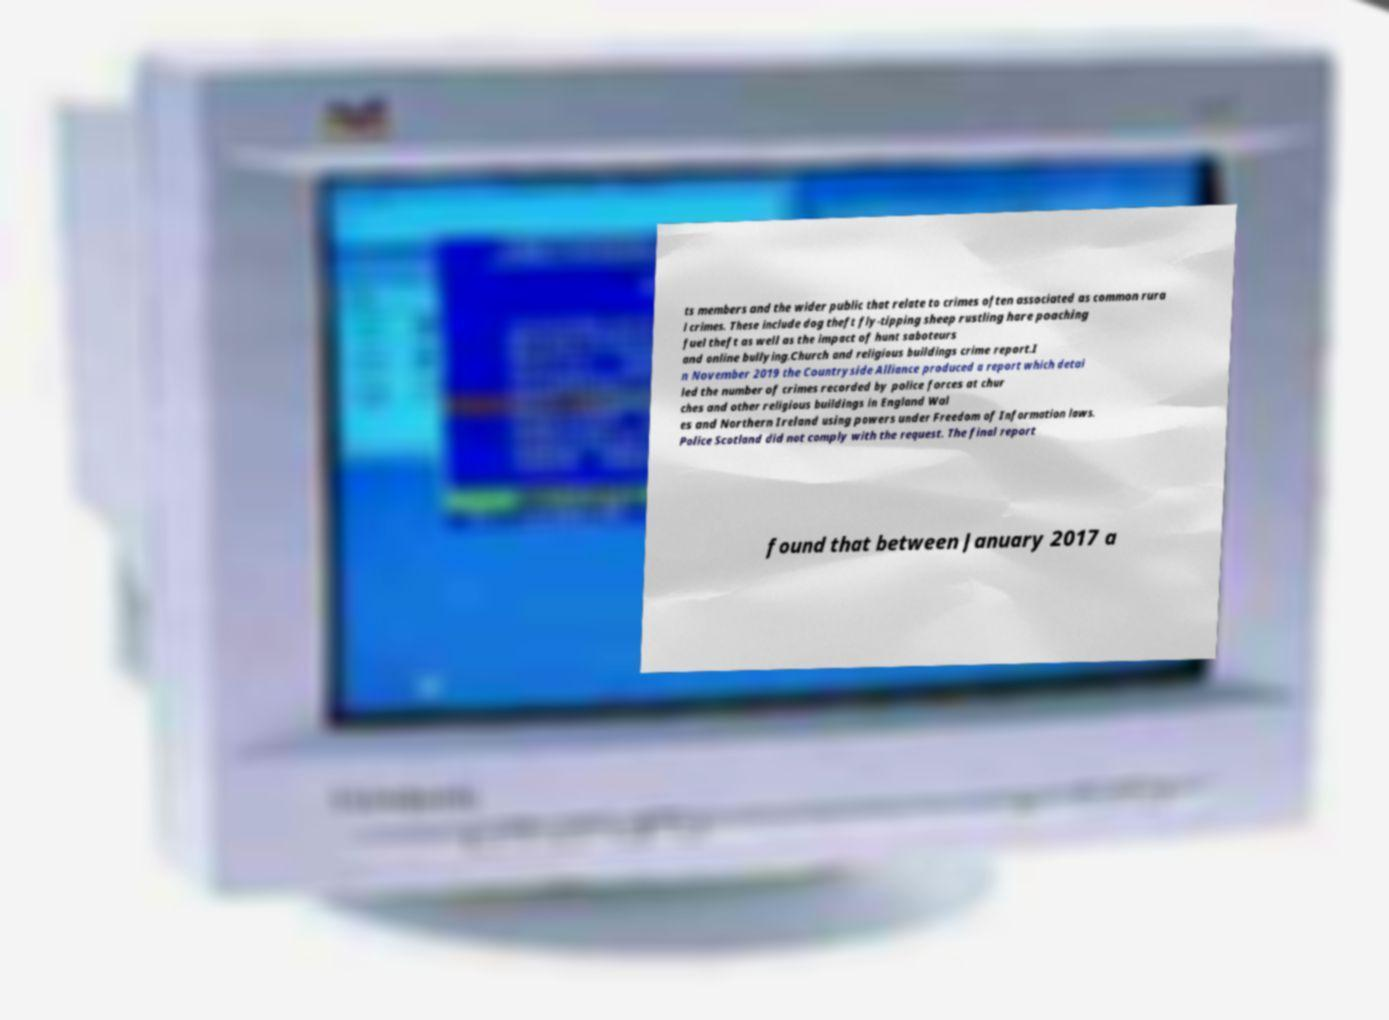Could you assist in decoding the text presented in this image and type it out clearly? ts members and the wider public that relate to crimes often associated as common rura l crimes. These include dog theft fly-tipping sheep rustling hare poaching fuel theft as well as the impact of hunt saboteurs and online bullying.Church and religious buildings crime report.I n November 2019 the Countryside Alliance produced a report which detai led the number of crimes recorded by police forces at chur ches and other religious buildings in England Wal es and Northern Ireland using powers under Freedom of Information laws. Police Scotland did not comply with the request. The final report found that between January 2017 a 